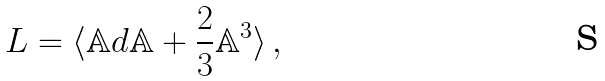Convert formula to latex. <formula><loc_0><loc_0><loc_500><loc_500>L = \langle \mathbb { A } d \mathbb { A } + \frac { 2 } { 3 } \mathbb { A } ^ { 3 } \rangle \, ,</formula> 